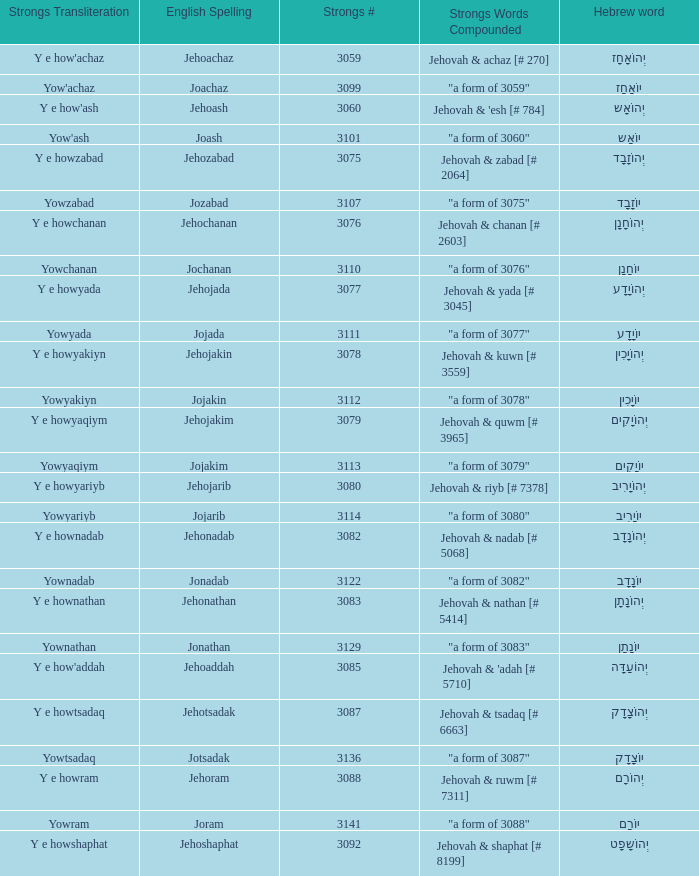What is the strongs # of the english spelling word jehojakin? 3078.0. 